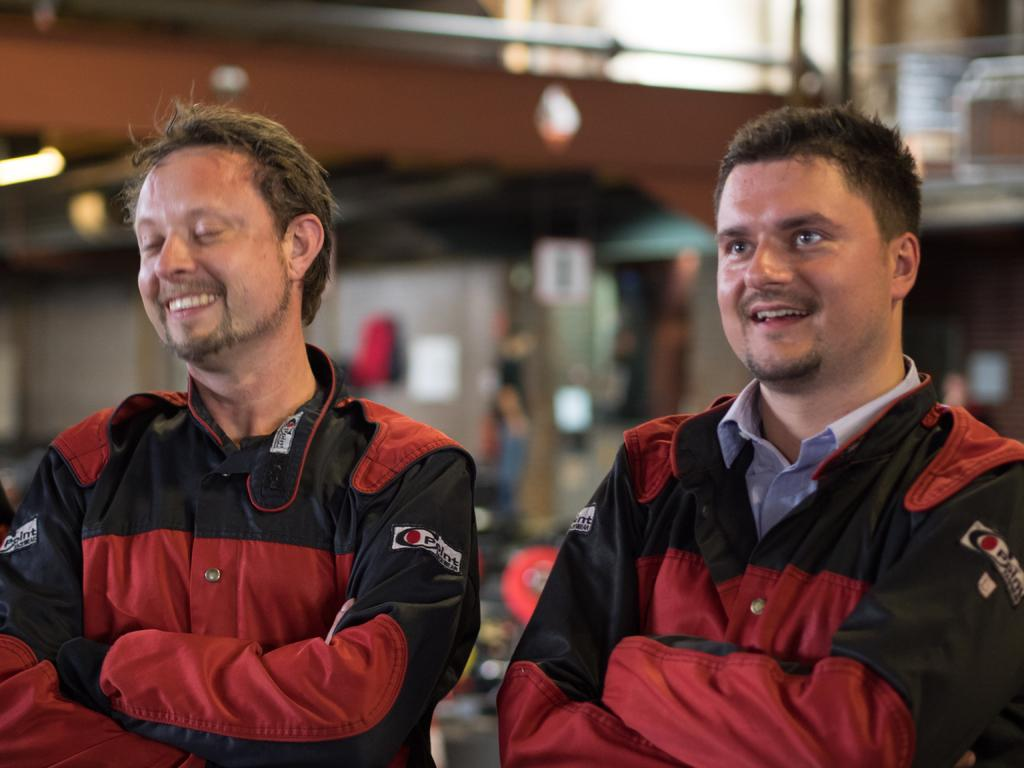How many people are in the image? There are two people in the image. What are the people doing in the image? The people are smiling and holding their hands. Can you describe the background of the image? The background of the image is blurred, but a wall and objects are visible. What else can be seen in the background? There are lights visible in the background. What is the topic of the discussion between the two people in the image? There is no discussion taking place in the image; the people are smiling and holding their hands. 